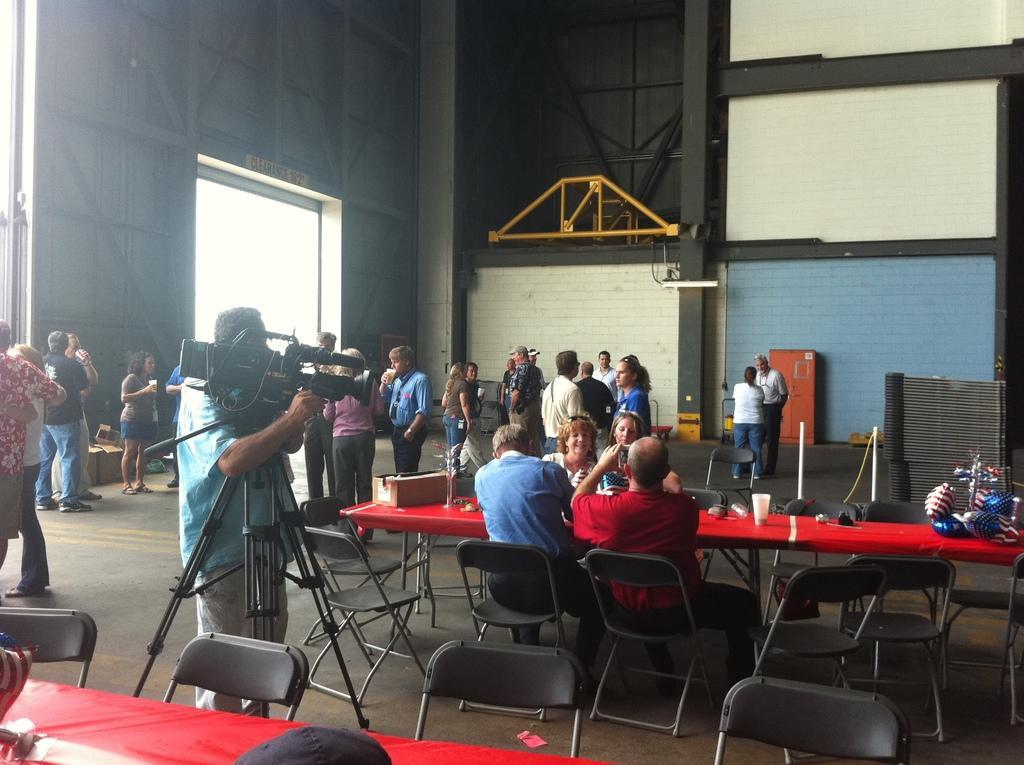In one or two sentences, can you explain what this image depicts? In this image there are people, wall and metal objects on the left corner. There is floor at the bottom. There are people, chairs, tables with objects on it and a person holding a camera in the foreground. There are people standing, there is a wall in the background.
And there are metal objects on the right corner. 